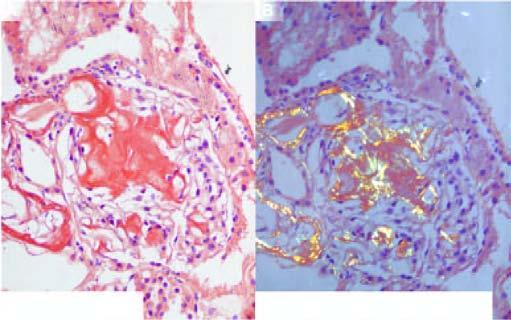do the lipofuscin pigment granules show apple-green birefringence?
Answer the question using a single word or phrase. No 